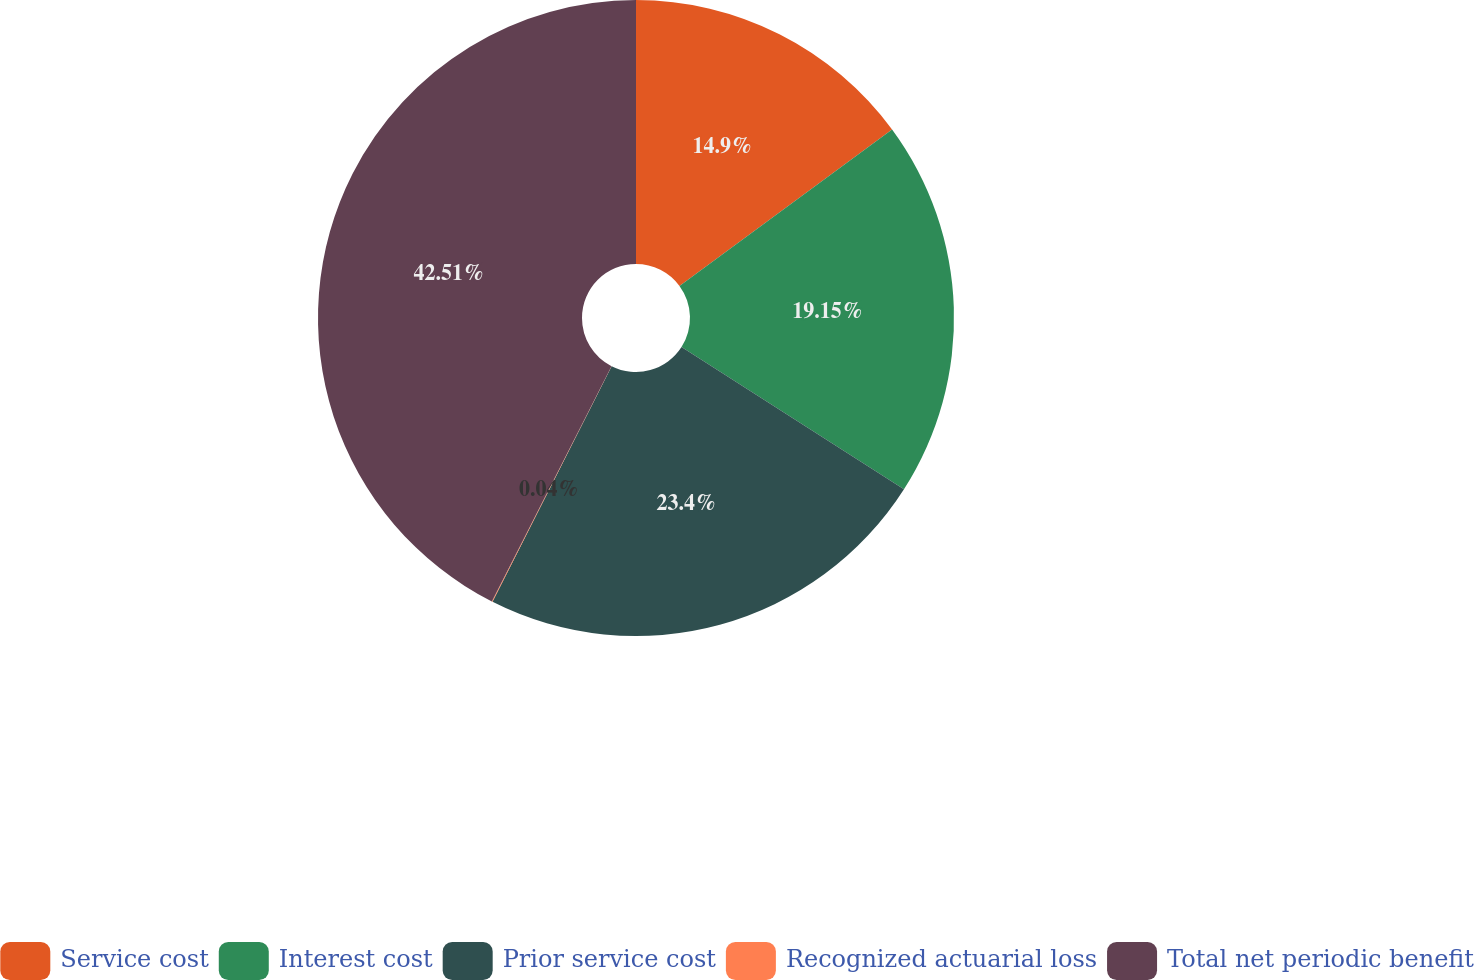Convert chart. <chart><loc_0><loc_0><loc_500><loc_500><pie_chart><fcel>Service cost<fcel>Interest cost<fcel>Prior service cost<fcel>Recognized actuarial loss<fcel>Total net periodic benefit<nl><fcel>14.9%<fcel>19.15%<fcel>23.4%<fcel>0.04%<fcel>42.51%<nl></chart> 